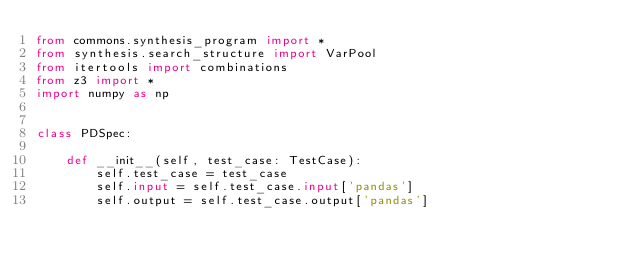Convert code to text. <code><loc_0><loc_0><loc_500><loc_500><_Python_>from commons.synthesis_program import *
from synthesis.search_structure import VarPool
from itertools import combinations
from z3 import *
import numpy as np


class PDSpec:

    def __init__(self, test_case: TestCase):
        self.test_case = test_case
        self.input = self.test_case.input['pandas']
        self.output = self.test_case.output['pandas']</code> 